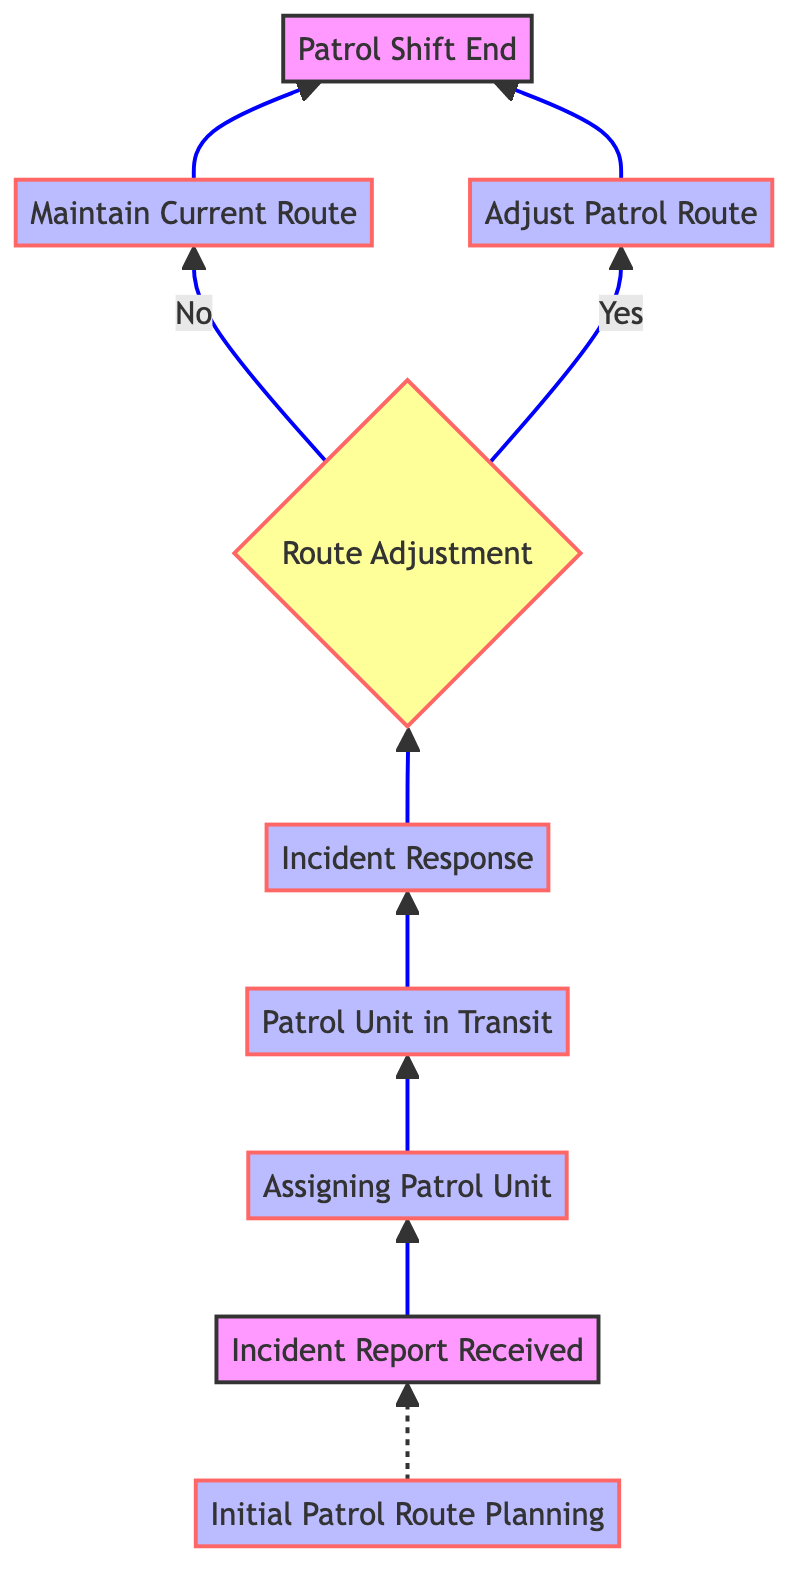What is the starting point of the process? The starting point is represented by the node labeled "Incident Report Received." This node initiates the flow of the flowchart and has no previous nodes.
Answer: Incident Report Received How many process nodes are in the diagram? By counting the nodes labeled as "Process," there are four in total: "Assigning Patrol Unit," "Patrol Unit in Transit," "Incident Response," and "Maintain Current Route" or "Adjust Patrol Route."
Answer: Four What decision is made after the "Incident Response"? The decision made immediately after "Incident Response" is whether to adjust the patrol route based on incident reports. This decision is the only decision node following that step.
Answer: Route Adjustment If the patrol unit decides to adjust the route, which process is followed? If the patrol unit decides to adjust the route, the process that follows is "Adjust Patrol Route." This process directly follows the "Route Adjustment" decision if the answer is "Yes."
Answer: Adjust Patrol Route What confirms the end of the patrol shift? The conclusion of the patrol shift is confirmed by the "Patrol Shift End" node, which is the final node in the flowchart, coming as a result of either maintaining or adjusting the patrol route.
Answer: Patrol Shift End Which node represents the planning stage of patrol routes? The node that represents the planning stage of patrol routes is "Initial Patrol Route Planning," detailing the planning efforts before any incidents are reported.
Answer: Initial Patrol Route Planning What happens if the decision is made to maintain the current patrol route? If the decision is made to maintain the current patrol route, the flowchart directs to the "Maintain Current Route" process, confirming no changes in the patrol strategy.
Answer: Maintain Current Route How many edges lead to the "Patrol Shift End" node? There are two edges leading to the "Patrol Shift End" node: one from "Maintain Current Route" and another from "Adjust Patrol Route." This reflects two possible paths to reach the shift end.
Answer: Two What is the first action taken after an incident report is received? The first action taken after receiving an incident report is the "Assigning Patrol Unit," where the dispatcher assigns a specific patrol unit to respond, marking the beginning of the response efforts.
Answer: Assigning Patrol Unit 